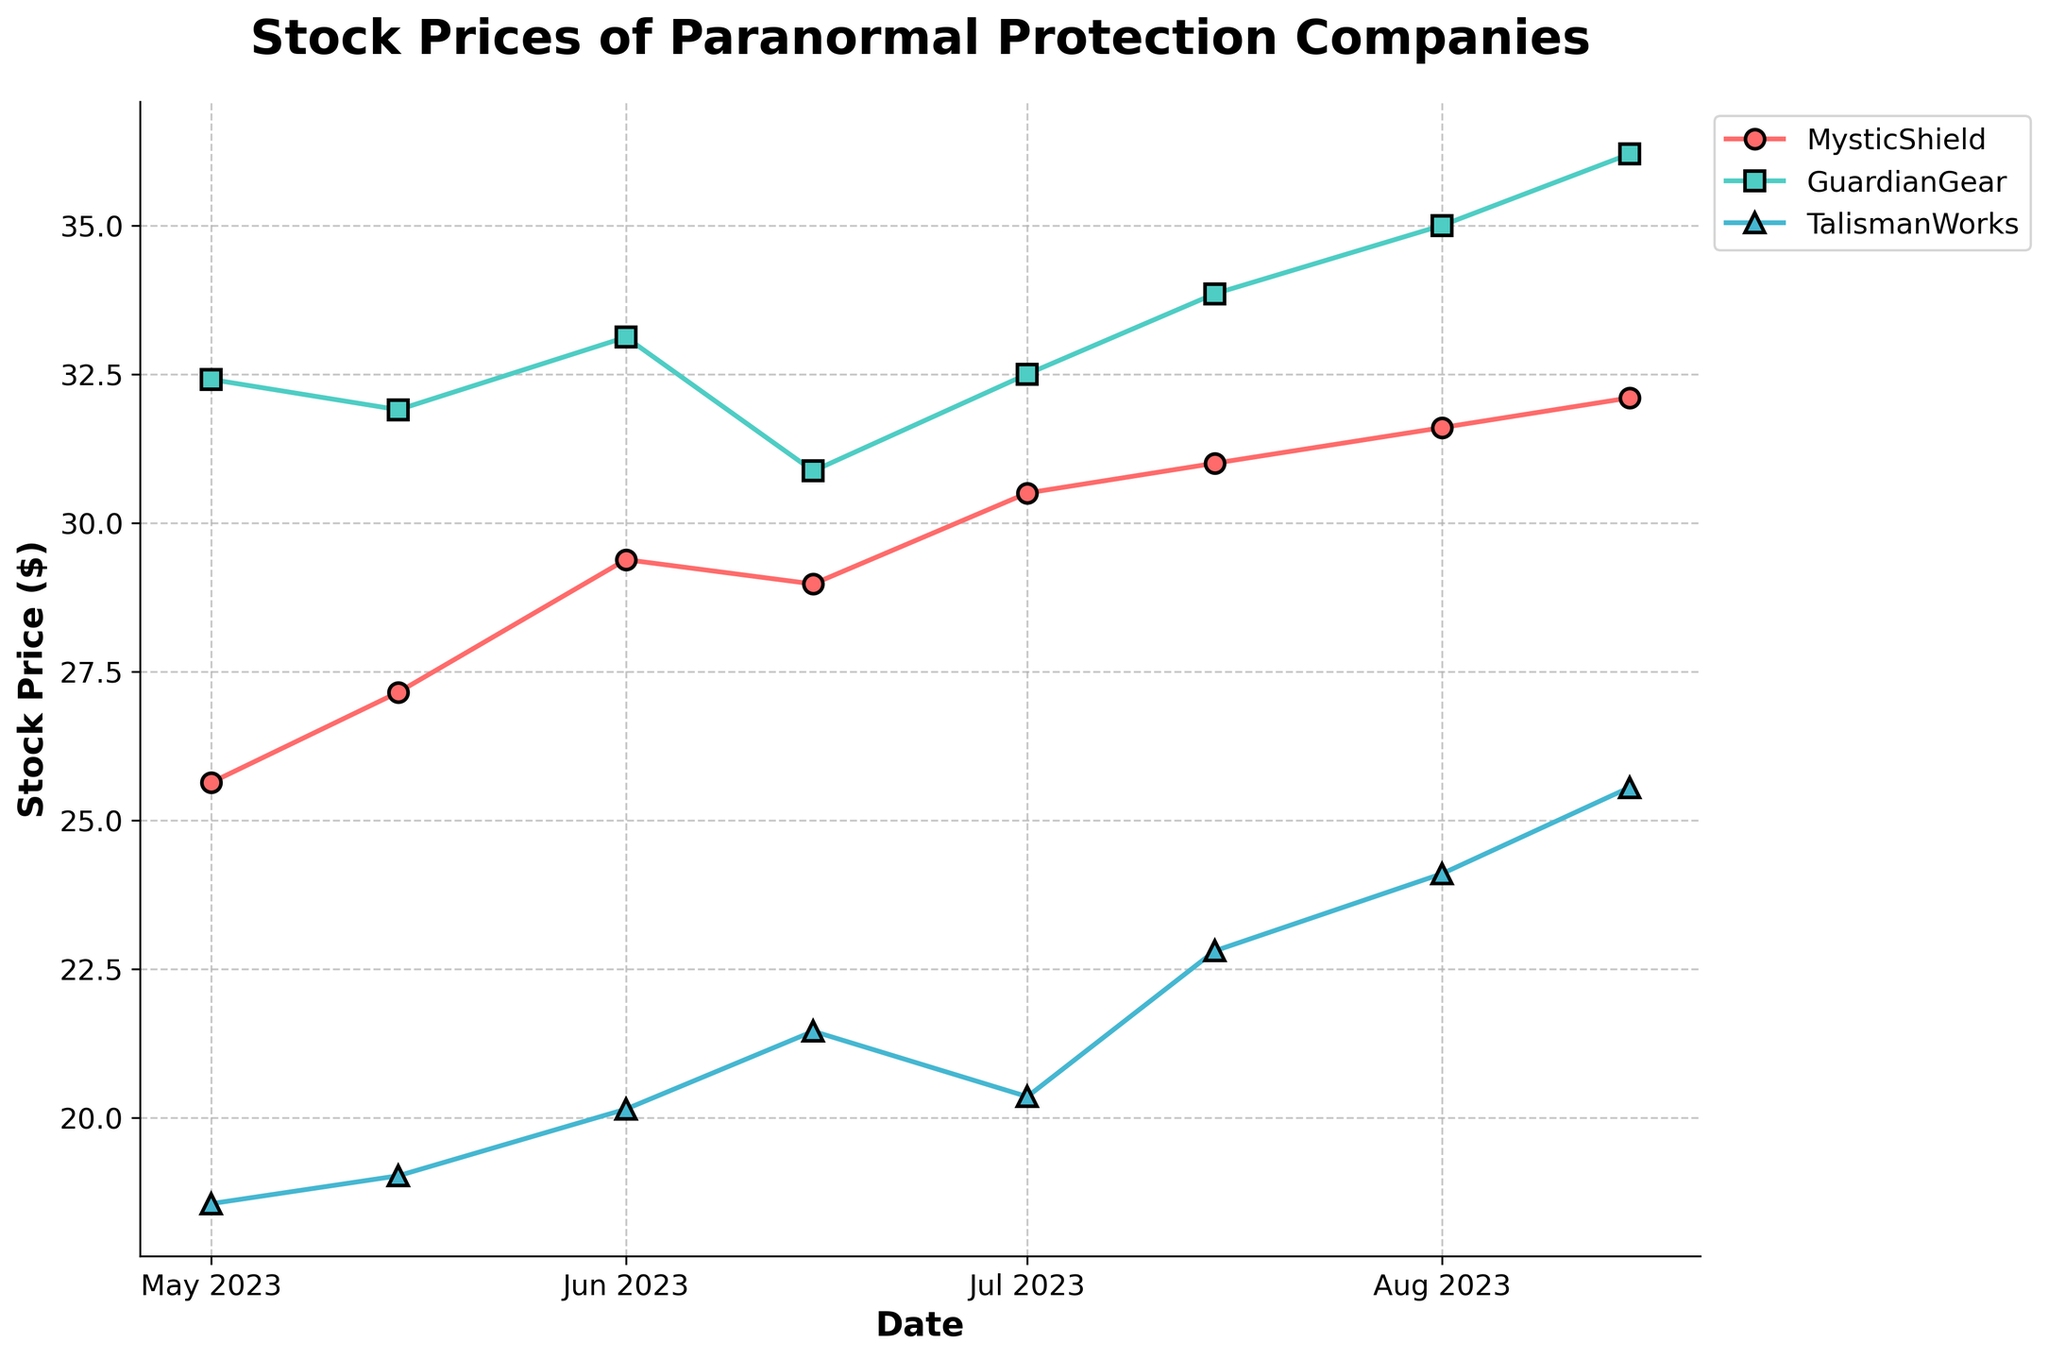What's the title of the figure? The title is prominently displayed at the top of the figure, providing a summary of what the plot represents.
Answer: Stock Prices of Paranormal Protection Companies How many different companies' stock prices are shown in the figure? Identify the number of unique legend entries representing different companies.
Answer: 3 Which company had the highest stock price on August 15, 2023? Locate the data points for August 15, 2023, for each company and compare stock prices.
Answer: GuardianGear How does the stock price of MysticShield on June 1, 2023, compare to that on July 1, 2023? Extract the stock prices for MysticShield on these dates and compare them.
Answer: It increased from 29.38 to 30.50 What is the overall trend of TalismanWorks' stock price from May 1, 2023, to August 15, 2023? Observe the line graph for TalismanWorks and note the direction of the trend over the specified period.
Answer: Increasing What's the average stock price of GuardianGear over the entire period? Sum the stock prices of GuardianGear over all dates and divide by the number of data points.
Answer: 33.31 On which date did MysticShield experience its steepest increase in stock price? Compare the slopes of the line segments for MysticShield to find the greatest positive change between consecutive dates.
Answer: July 1, 2023 Between June 15, 2023, and August 1, 2023, which company had the most consistent stock price? Assess the stability of stock prices by observing the least fluctuations in the lines of the companies over the specified period.
Answer: GuardianGear What is the range of stock prices for TalismanWorks over the plotted period? Deduce the range by subtracting the minimum stock price of TalismanWorks from the maximum stock price over all dates.
Answer: 25.55 - 18.55 = 7.00 